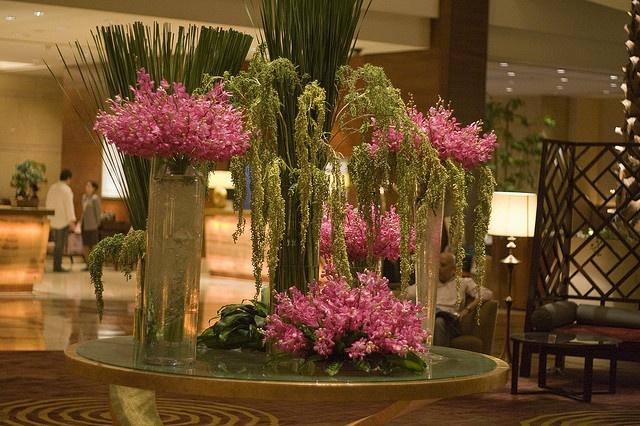Describe the objects in this image and their specific colors. I can see dining table in olive, maroon, and black tones, vase in olive and black tones, vase in olive, black, and gray tones, couch in olive, black, maroon, and gray tones, and vase in olive, gray, and maroon tones in this image. 